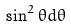Convert formula to latex. <formula><loc_0><loc_0><loc_500><loc_500>\sin ^ { 2 } \theta d \theta</formula> 